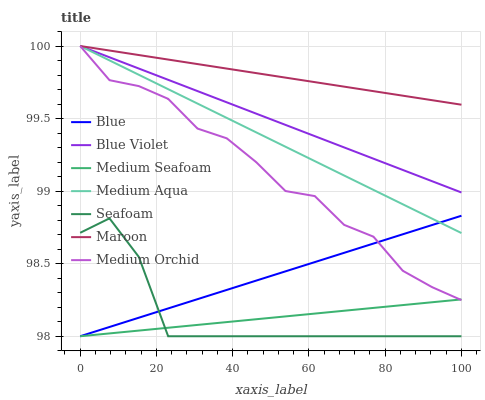Does Medium Seafoam have the minimum area under the curve?
Answer yes or no. Yes. Does Maroon have the maximum area under the curve?
Answer yes or no. Yes. Does Medium Orchid have the minimum area under the curve?
Answer yes or no. No. Does Medium Orchid have the maximum area under the curve?
Answer yes or no. No. Is Medium Seafoam the smoothest?
Answer yes or no. Yes. Is Medium Orchid the roughest?
Answer yes or no. Yes. Is Seafoam the smoothest?
Answer yes or no. No. Is Seafoam the roughest?
Answer yes or no. No. Does Blue have the lowest value?
Answer yes or no. Yes. Does Medium Orchid have the lowest value?
Answer yes or no. No. Does Blue Violet have the highest value?
Answer yes or no. Yes. Does Seafoam have the highest value?
Answer yes or no. No. Is Seafoam less than Maroon?
Answer yes or no. Yes. Is Maroon greater than Blue?
Answer yes or no. Yes. Does Medium Seafoam intersect Seafoam?
Answer yes or no. Yes. Is Medium Seafoam less than Seafoam?
Answer yes or no. No. Is Medium Seafoam greater than Seafoam?
Answer yes or no. No. Does Seafoam intersect Maroon?
Answer yes or no. No. 